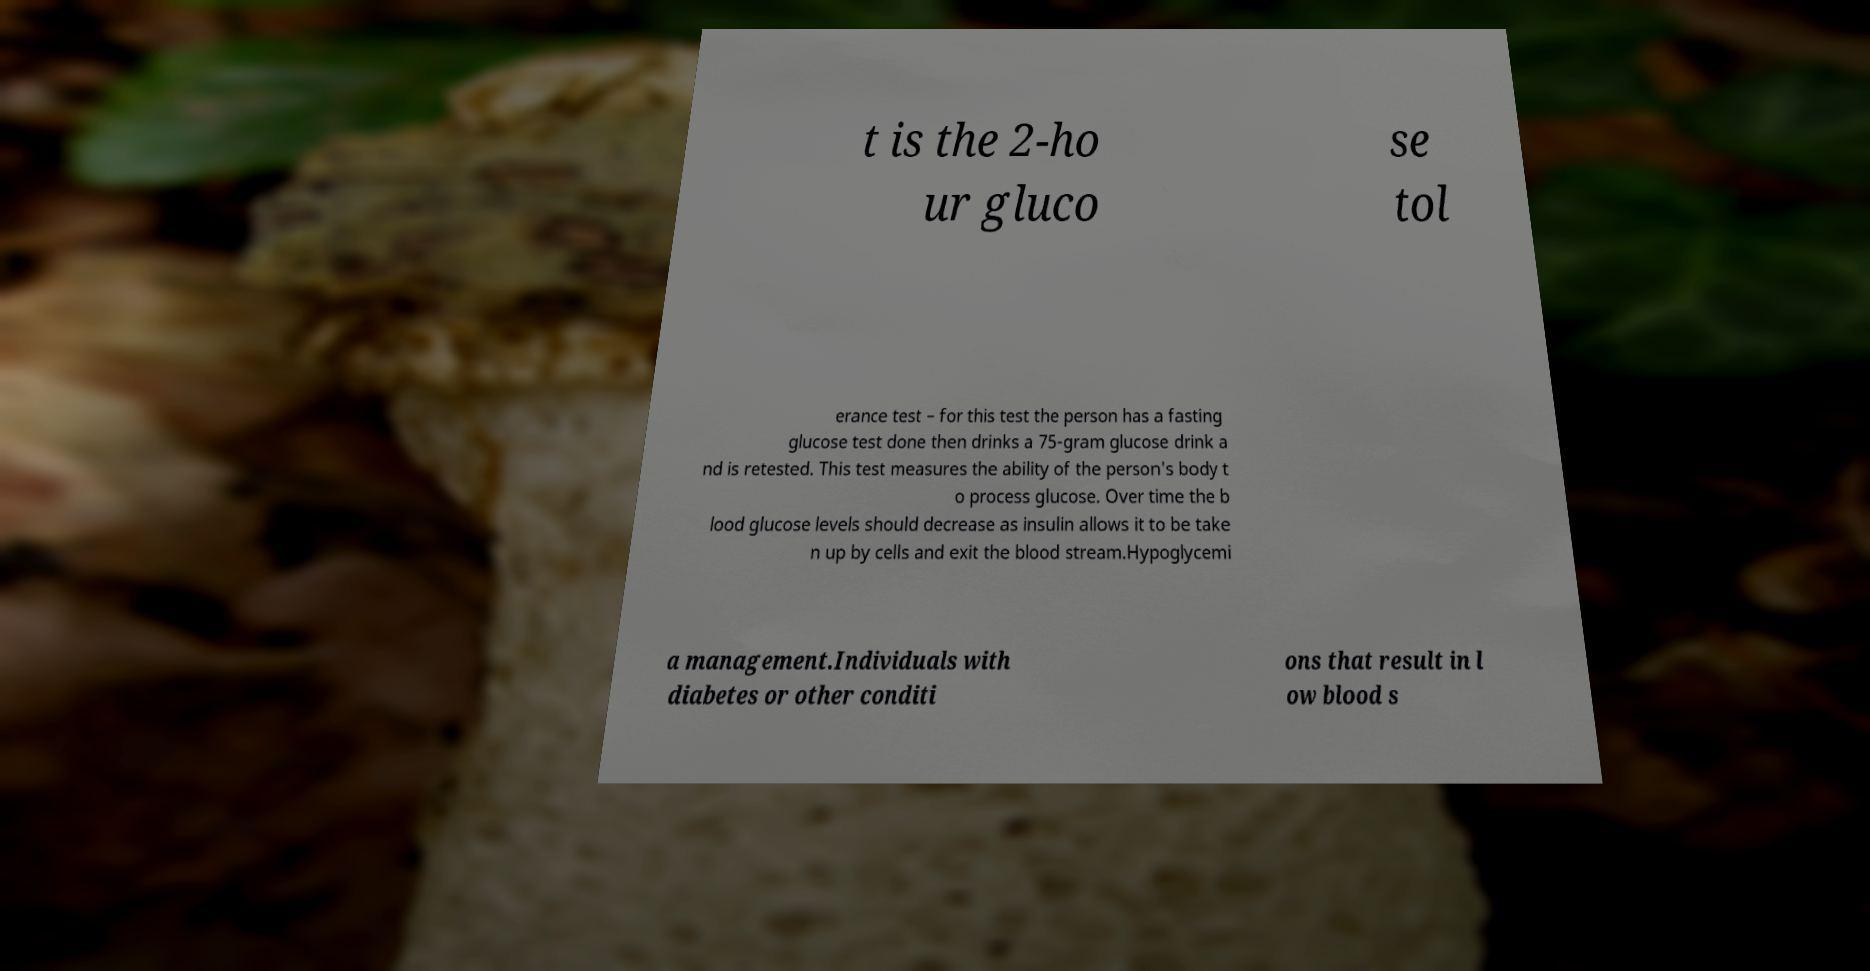Can you accurately transcribe the text from the provided image for me? t is the 2-ho ur gluco se tol erance test – for this test the person has a fasting glucose test done then drinks a 75-gram glucose drink a nd is retested. This test measures the ability of the person's body t o process glucose. Over time the b lood glucose levels should decrease as insulin allows it to be take n up by cells and exit the blood stream.Hypoglycemi a management.Individuals with diabetes or other conditi ons that result in l ow blood s 